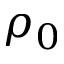<formula> <loc_0><loc_0><loc_500><loc_500>\rho _ { 0 }</formula> 